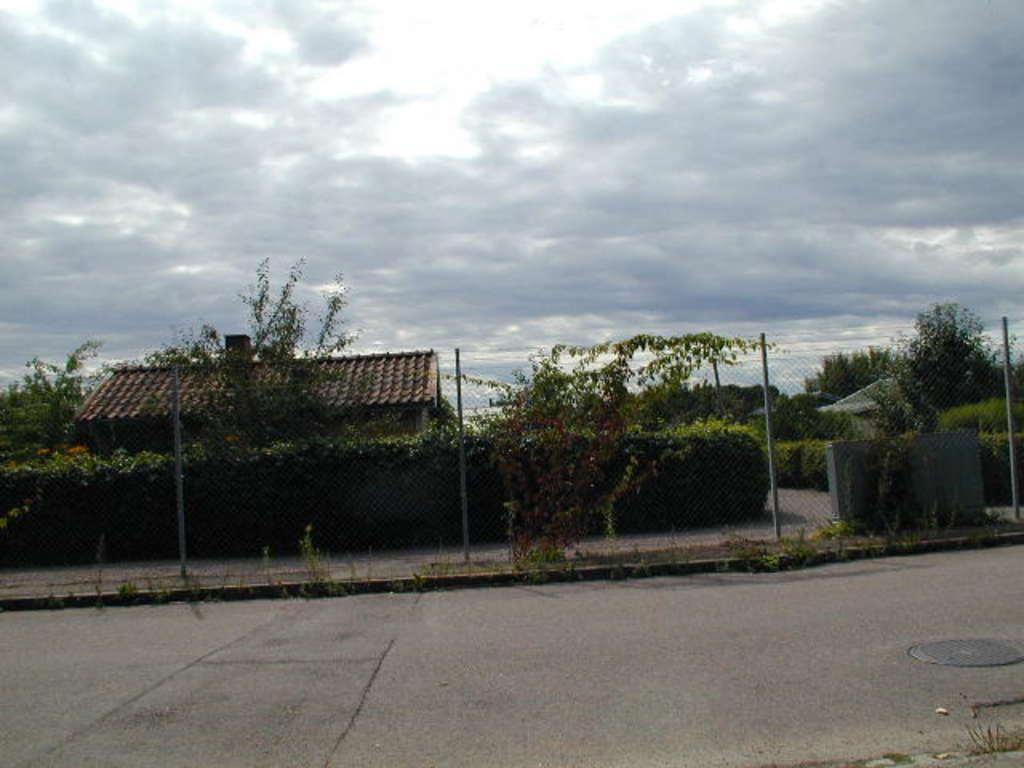In one or two sentences, can you explain what this image depicts? In this image we can see a few houses, there are some poles, trees, plants, grass, fence and other objects, in the background we can see the sky. 